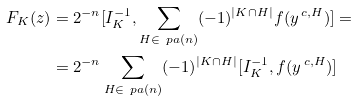Convert formula to latex. <formula><loc_0><loc_0><loc_500><loc_500>F _ { K } ( z ) & = 2 ^ { - n } [ I _ { K } ^ { - 1 } , \sum _ { H \in \ p a ( n ) } ( - 1 ) ^ { | K \cap H | } f ( y ^ { \, c , H } ) ] = \\ & = 2 ^ { - n } \sum _ { H \in \ p a ( n ) } ( - 1 ) ^ { | K \cap H | } [ I _ { K } ^ { - 1 } , f ( y ^ { \, c , H } ) ]</formula> 